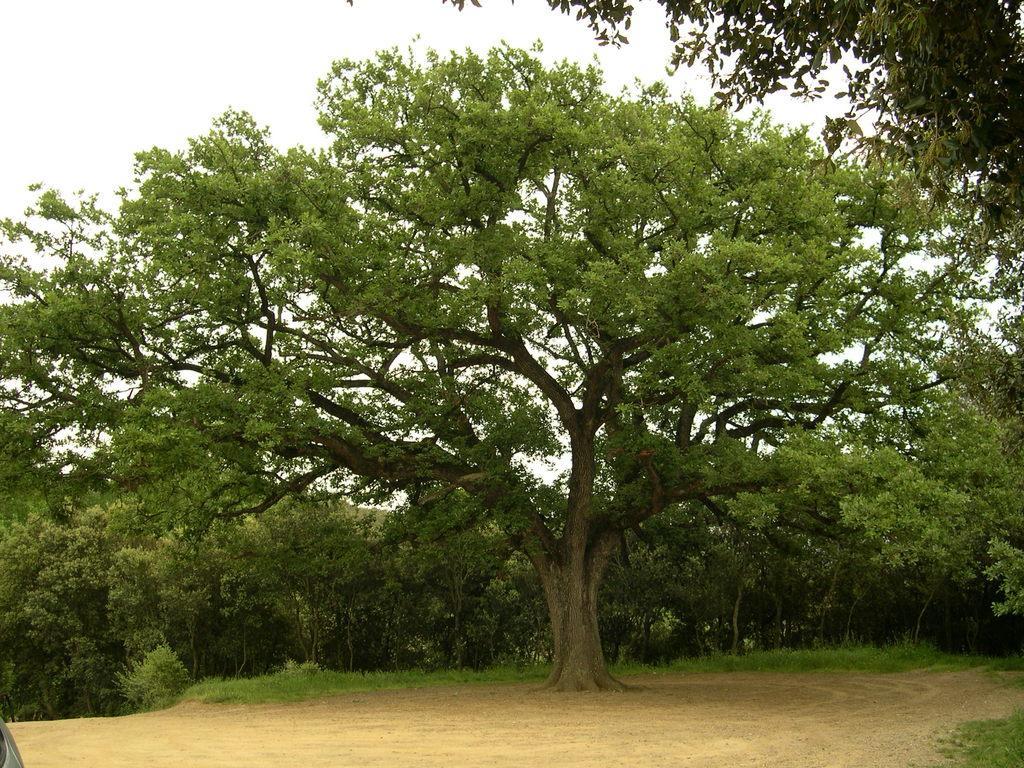Can you describe this image briefly? In this image I can see the ground and few trees which are green and brown in color. In the background I can see the sky. 